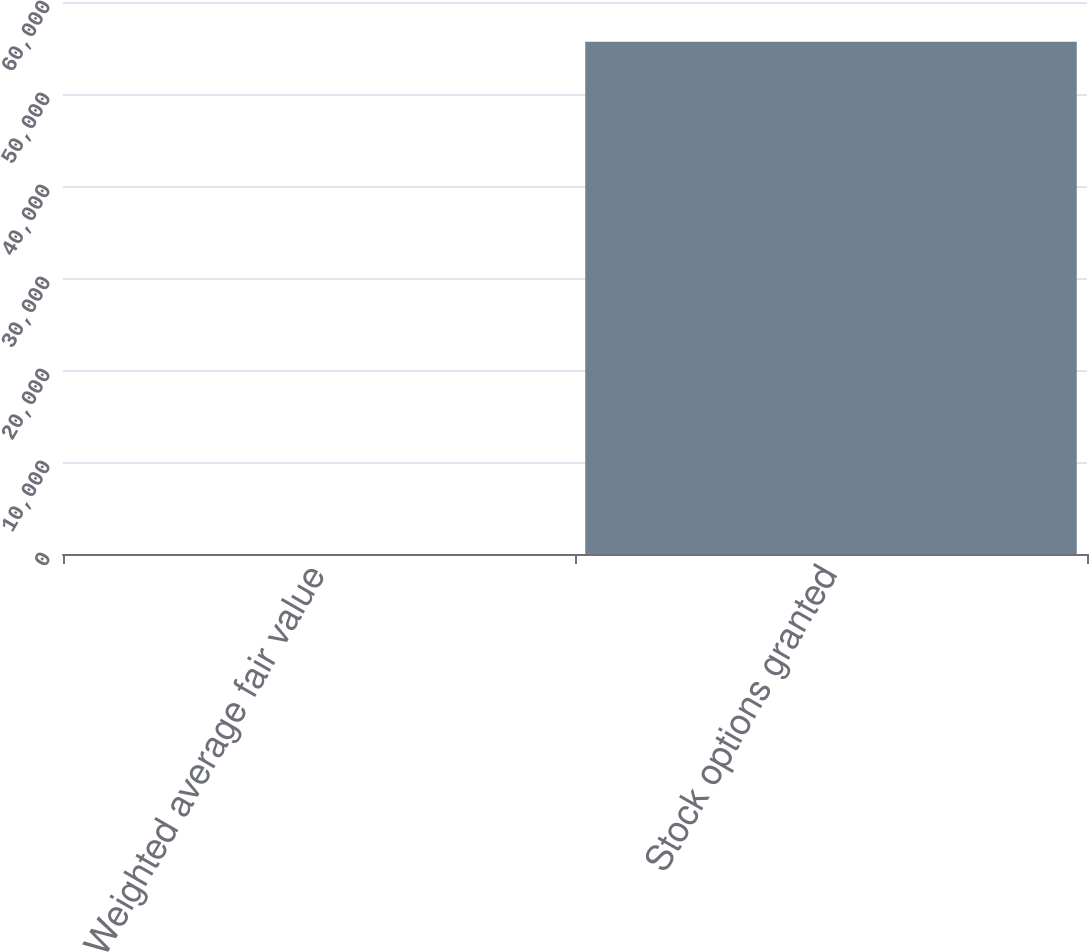Convert chart to OTSL. <chart><loc_0><loc_0><loc_500><loc_500><bar_chart><fcel>Weighted average fair value<fcel>Stock options granted<nl><fcel>0.93<fcel>55668<nl></chart> 